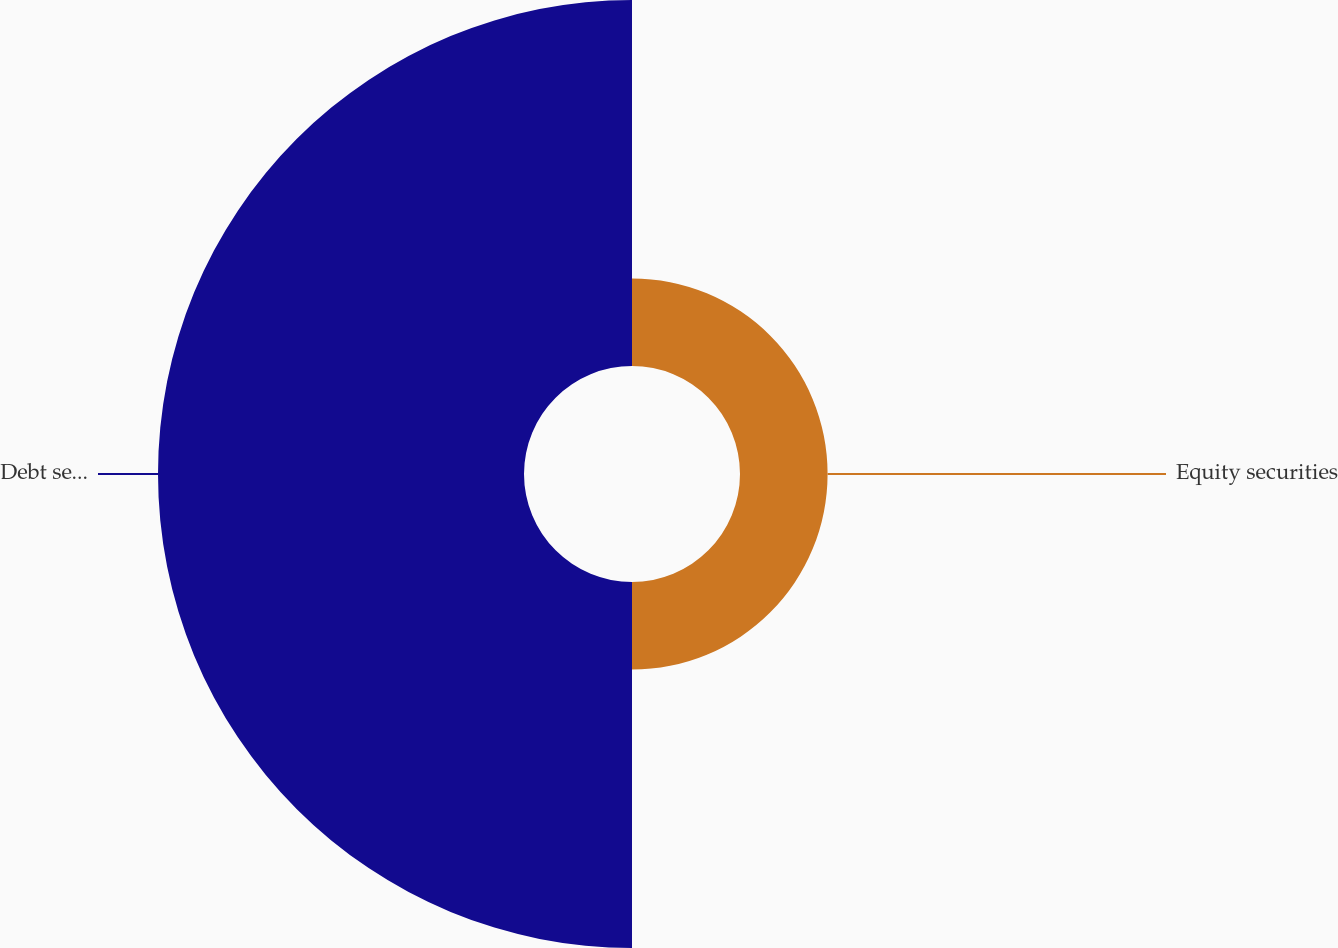Convert chart to OTSL. <chart><loc_0><loc_0><loc_500><loc_500><pie_chart><fcel>Equity securities<fcel>Debt securities<nl><fcel>19.31%<fcel>80.69%<nl></chart> 